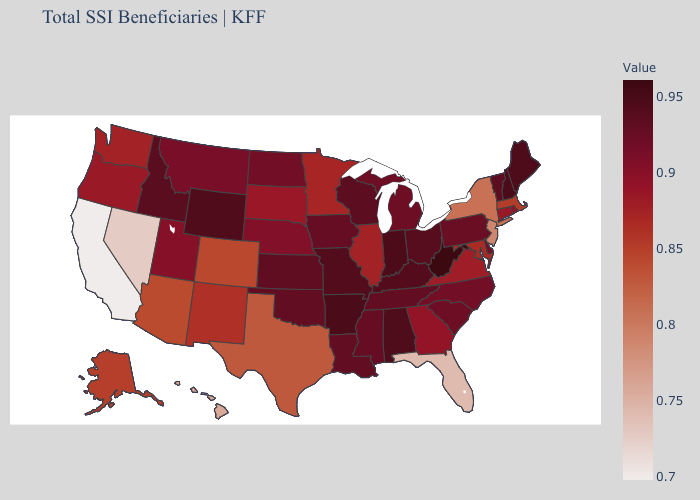Does Mississippi have the lowest value in the USA?
Give a very brief answer. No. Among the states that border Ohio , does West Virginia have the highest value?
Quick response, please. Yes. Which states have the lowest value in the South?
Short answer required. Florida. Does New York have a lower value than Hawaii?
Answer briefly. No. Among the states that border Arizona , does Colorado have the highest value?
Be succinct. No. Among the states that border New Mexico , which have the highest value?
Keep it brief. Oklahoma. Which states have the lowest value in the USA?
Answer briefly. California. 